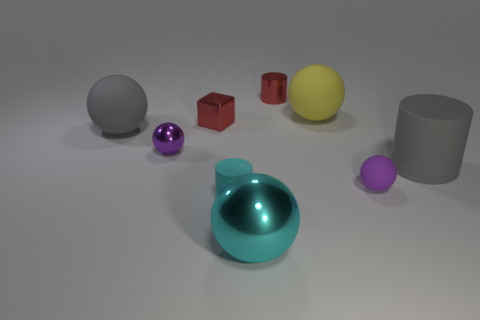Are the gray cylinder and the big yellow thing made of the same material?
Ensure brevity in your answer.  Yes. What number of yellow things are metal things or big shiny spheres?
Your answer should be very brief. 0. What number of big cyan shiny things have the same shape as the big yellow thing?
Offer a terse response. 1. What is the gray cylinder made of?
Ensure brevity in your answer.  Rubber. Are there the same number of big cyan shiny balls that are right of the tiny purple matte sphere and green shiny blocks?
Provide a succinct answer. Yes. The cyan rubber thing that is the same size as the red cube is what shape?
Keep it short and to the point. Cylinder. Are there any large gray rubber things to the left of the rubber cylinder that is in front of the gray matte cylinder?
Offer a terse response. Yes. How many small objects are purple metallic balls or gray matte cylinders?
Ensure brevity in your answer.  1. Is there a purple object that has the same size as the gray matte sphere?
Make the answer very short. No. How many metallic things are either big objects or gray things?
Provide a succinct answer. 1. 